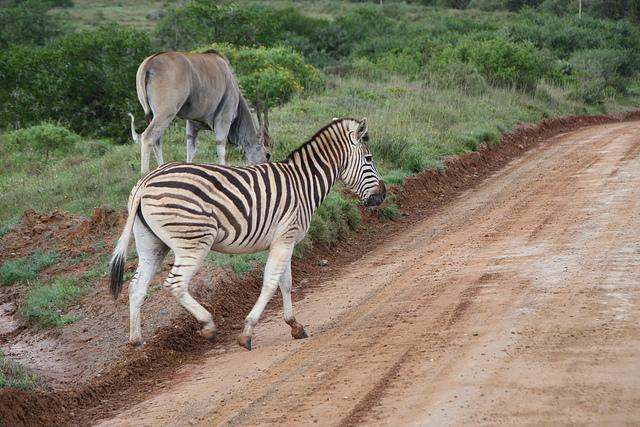What is the zebra on the left about to step into? Please explain your reasoning. road. Two animals are walking along a dirt road in a grassy area. 